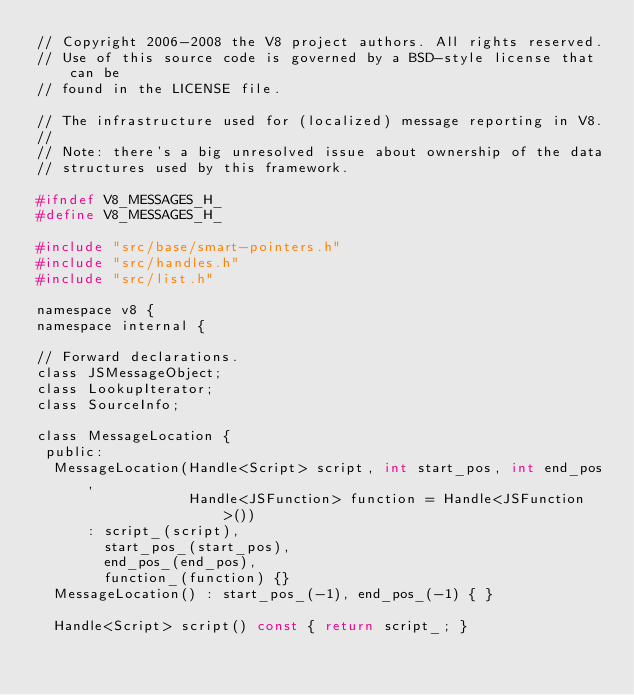<code> <loc_0><loc_0><loc_500><loc_500><_C_>// Copyright 2006-2008 the V8 project authors. All rights reserved.
// Use of this source code is governed by a BSD-style license that can be
// found in the LICENSE file.

// The infrastructure used for (localized) message reporting in V8.
//
// Note: there's a big unresolved issue about ownership of the data
// structures used by this framework.

#ifndef V8_MESSAGES_H_
#define V8_MESSAGES_H_

#include "src/base/smart-pointers.h"
#include "src/handles.h"
#include "src/list.h"

namespace v8 {
namespace internal {

// Forward declarations.
class JSMessageObject;
class LookupIterator;
class SourceInfo;

class MessageLocation {
 public:
  MessageLocation(Handle<Script> script, int start_pos, int end_pos,
                  Handle<JSFunction> function = Handle<JSFunction>())
      : script_(script),
        start_pos_(start_pos),
        end_pos_(end_pos),
        function_(function) {}
  MessageLocation() : start_pos_(-1), end_pos_(-1) { }

  Handle<Script> script() const { return script_; }</code> 